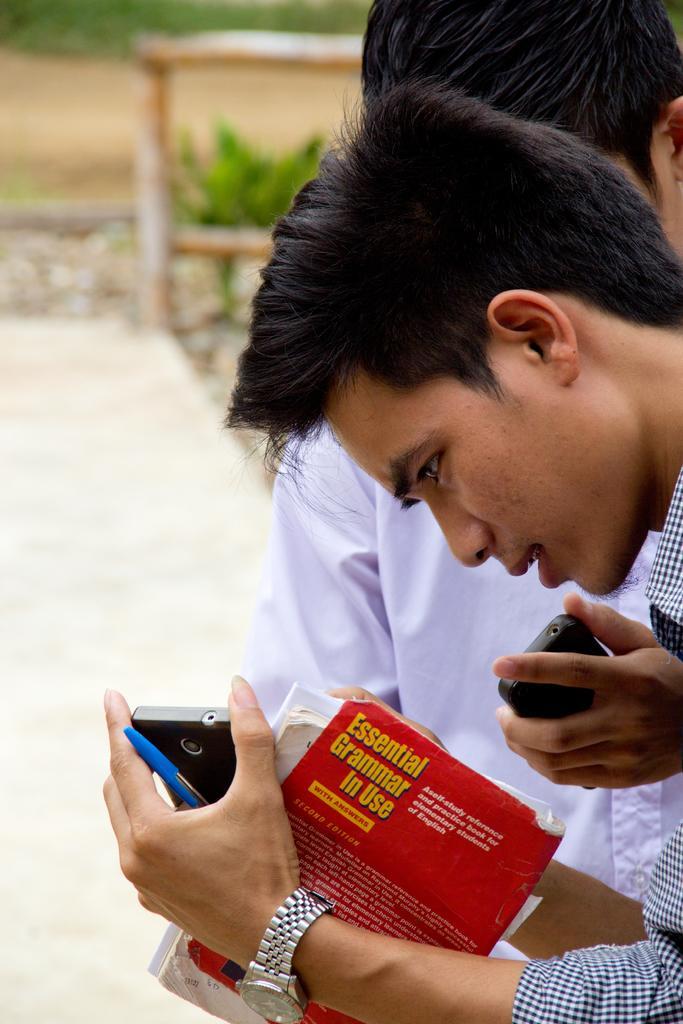Please provide a concise description of this image. In this image i can see two persons holding book and a mobile at the back ground i can see small plant, a wooden pole and a road. 